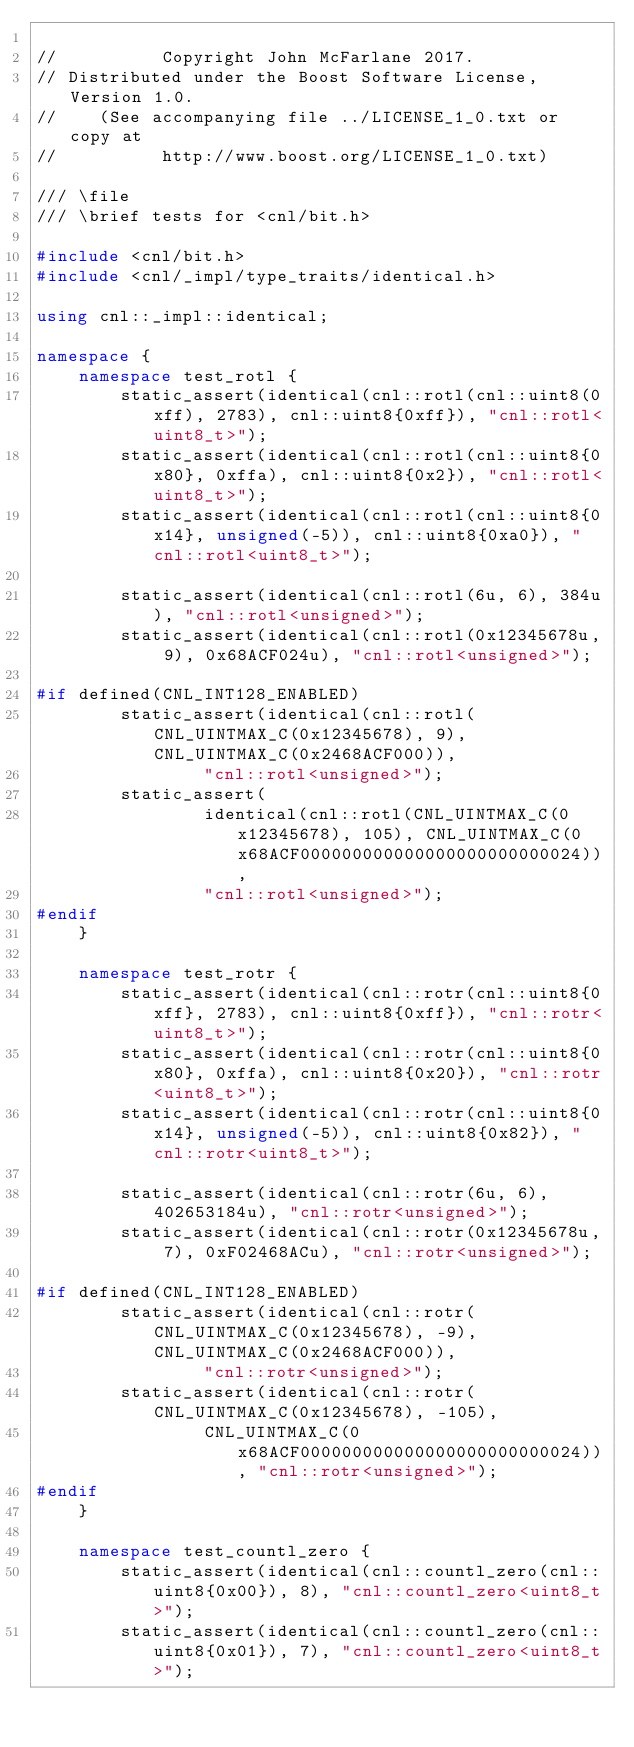<code> <loc_0><loc_0><loc_500><loc_500><_C++_>
//          Copyright John McFarlane 2017.
// Distributed under the Boost Software License, Version 1.0.
//    (See accompanying file ../LICENSE_1_0.txt or copy at
//          http://www.boost.org/LICENSE_1_0.txt)

/// \file
/// \brief tests for <cnl/bit.h>

#include <cnl/bit.h>
#include <cnl/_impl/type_traits/identical.h>

using cnl::_impl::identical;

namespace {
    namespace test_rotl {
        static_assert(identical(cnl::rotl(cnl::uint8(0xff), 2783), cnl::uint8{0xff}), "cnl::rotl<uint8_t>");
        static_assert(identical(cnl::rotl(cnl::uint8{0x80}, 0xffa), cnl::uint8{0x2}), "cnl::rotl<uint8_t>");
        static_assert(identical(cnl::rotl(cnl::uint8{0x14}, unsigned(-5)), cnl::uint8{0xa0}), "cnl::rotl<uint8_t>");

        static_assert(identical(cnl::rotl(6u, 6), 384u), "cnl::rotl<unsigned>");
        static_assert(identical(cnl::rotl(0x12345678u, 9), 0x68ACF024u), "cnl::rotl<unsigned>");

#if defined(CNL_INT128_ENABLED)
        static_assert(identical(cnl::rotl(CNL_UINTMAX_C(0x12345678), 9), CNL_UINTMAX_C(0x2468ACF000)),
                "cnl::rotl<unsigned>");
        static_assert(
                identical(cnl::rotl(CNL_UINTMAX_C(0x12345678), 105), CNL_UINTMAX_C(0x68ACF000000000000000000000000024)),
                "cnl::rotl<unsigned>");
#endif
    }

    namespace test_rotr {
        static_assert(identical(cnl::rotr(cnl::uint8{0xff}, 2783), cnl::uint8{0xff}), "cnl::rotr<uint8_t>");
        static_assert(identical(cnl::rotr(cnl::uint8{0x80}, 0xffa), cnl::uint8{0x20}), "cnl::rotr<uint8_t>");
        static_assert(identical(cnl::rotr(cnl::uint8{0x14}, unsigned(-5)), cnl::uint8{0x82}), "cnl::rotr<uint8_t>");

        static_assert(identical(cnl::rotr(6u, 6), 402653184u), "cnl::rotr<unsigned>");
        static_assert(identical(cnl::rotr(0x12345678u, 7), 0xF02468ACu), "cnl::rotr<unsigned>");

#if defined(CNL_INT128_ENABLED)
        static_assert(identical(cnl::rotr(CNL_UINTMAX_C(0x12345678), -9), CNL_UINTMAX_C(0x2468ACF000)),
                "cnl::rotr<unsigned>");
        static_assert(identical(cnl::rotr(CNL_UINTMAX_C(0x12345678), -105),
                CNL_UINTMAX_C(0x68ACF000000000000000000000000024)), "cnl::rotr<unsigned>");
#endif
    }

    namespace test_countl_zero {
        static_assert(identical(cnl::countl_zero(cnl::uint8{0x00}), 8), "cnl::countl_zero<uint8_t>");
        static_assert(identical(cnl::countl_zero(cnl::uint8{0x01}), 7), "cnl::countl_zero<uint8_t>");</code> 